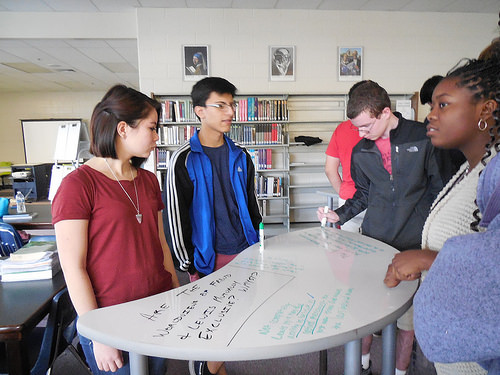<image>
Is there a painting on the shelf? No. The painting is not positioned on the shelf. They may be near each other, but the painting is not supported by or resting on top of the shelf. Where is the boy in relation to the girl? Is it next to the girl? No. The boy is not positioned next to the girl. They are located in different areas of the scene. 